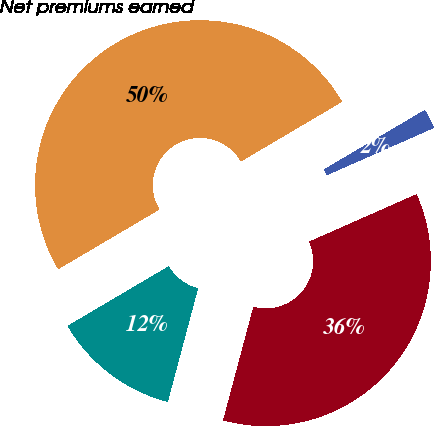Convert chart to OTSL. <chart><loc_0><loc_0><loc_500><loc_500><pie_chart><fcel>Property and all other<fcel>Casualty<fcel>Personal accident (A&H)<fcel>Net premiums earned<nl><fcel>12.37%<fcel>35.77%<fcel>1.86%<fcel>50.0%<nl></chart> 